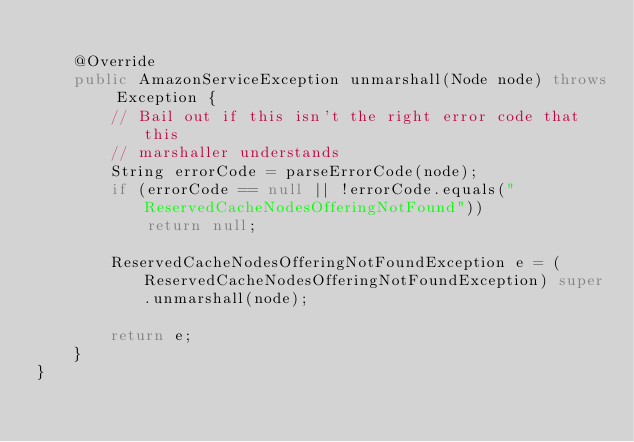Convert code to text. <code><loc_0><loc_0><loc_500><loc_500><_Java_>
    @Override
    public AmazonServiceException unmarshall(Node node) throws Exception {
        // Bail out if this isn't the right error code that this
        // marshaller understands
        String errorCode = parseErrorCode(node);
        if (errorCode == null || !errorCode.equals("ReservedCacheNodesOfferingNotFound"))
            return null;

        ReservedCacheNodesOfferingNotFoundException e = (ReservedCacheNodesOfferingNotFoundException) super.unmarshall(node);

        return e;
    }
}
</code> 